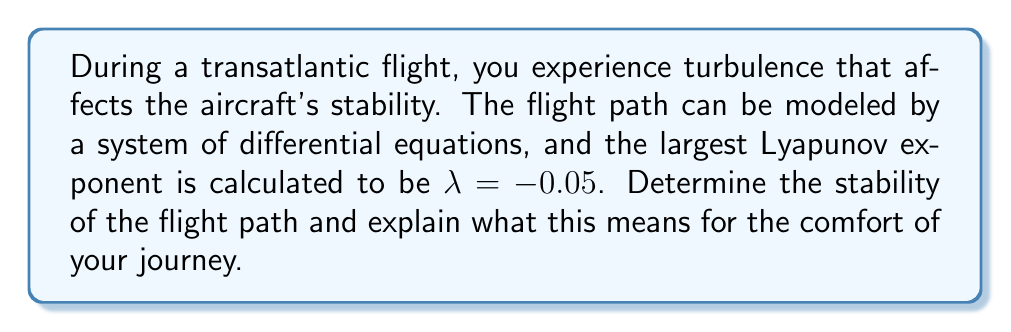Give your solution to this math problem. To determine the stability of the flight path using Lyapunov exponents, we follow these steps:

1) Recall that Lyapunov exponents measure the rate of separation of infinitesimally close trajectories in a dynamical system. 

2) The sign of the largest Lyapunov exponent ($\lambda$) indicates the stability of the system:
   - If $\lambda < 0$, the system is stable (attracting)
   - If $\lambda = 0$, the system is neutral (marginally stable)
   - If $\lambda > 0$, the system is unstable (chaotic)

3) In this case, we are given that $\lambda = -0.05$.

4) Since $\lambda < 0$, the flight path is stable.

5) To understand what this means for the comfort of the journey, we can look at the behavior of nearby trajectories:
   $$d(t) = d_0 e^{\lambda t}$$
   where $d(t)$ is the separation between trajectories at time $t$, and $d_0$ is the initial separation.

6) With $\lambda = -0.05$, the separation decreases over time:
   $$d(t) = d_0 e^{-0.05t}$$

7) This implies that even if turbulence momentarily perturbs the flight path, the aircraft will tend to return to its intended trajectory over time.

For a famous actor valuing discretion and professionalism, this stable flight path translates to a smooth and comfortable journey, allowing for privacy and minimal disruption during travel.
Answer: Stable flight path, ensuring a smooth and comfortable journey. 